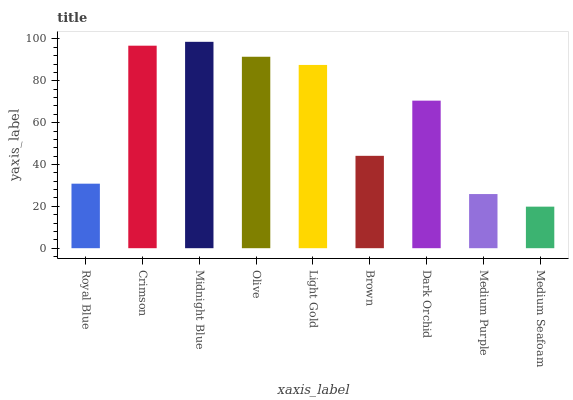Is Medium Seafoam the minimum?
Answer yes or no. Yes. Is Midnight Blue the maximum?
Answer yes or no. Yes. Is Crimson the minimum?
Answer yes or no. No. Is Crimson the maximum?
Answer yes or no. No. Is Crimson greater than Royal Blue?
Answer yes or no. Yes. Is Royal Blue less than Crimson?
Answer yes or no. Yes. Is Royal Blue greater than Crimson?
Answer yes or no. No. Is Crimson less than Royal Blue?
Answer yes or no. No. Is Dark Orchid the high median?
Answer yes or no. Yes. Is Dark Orchid the low median?
Answer yes or no. Yes. Is Medium Seafoam the high median?
Answer yes or no. No. Is Brown the low median?
Answer yes or no. No. 